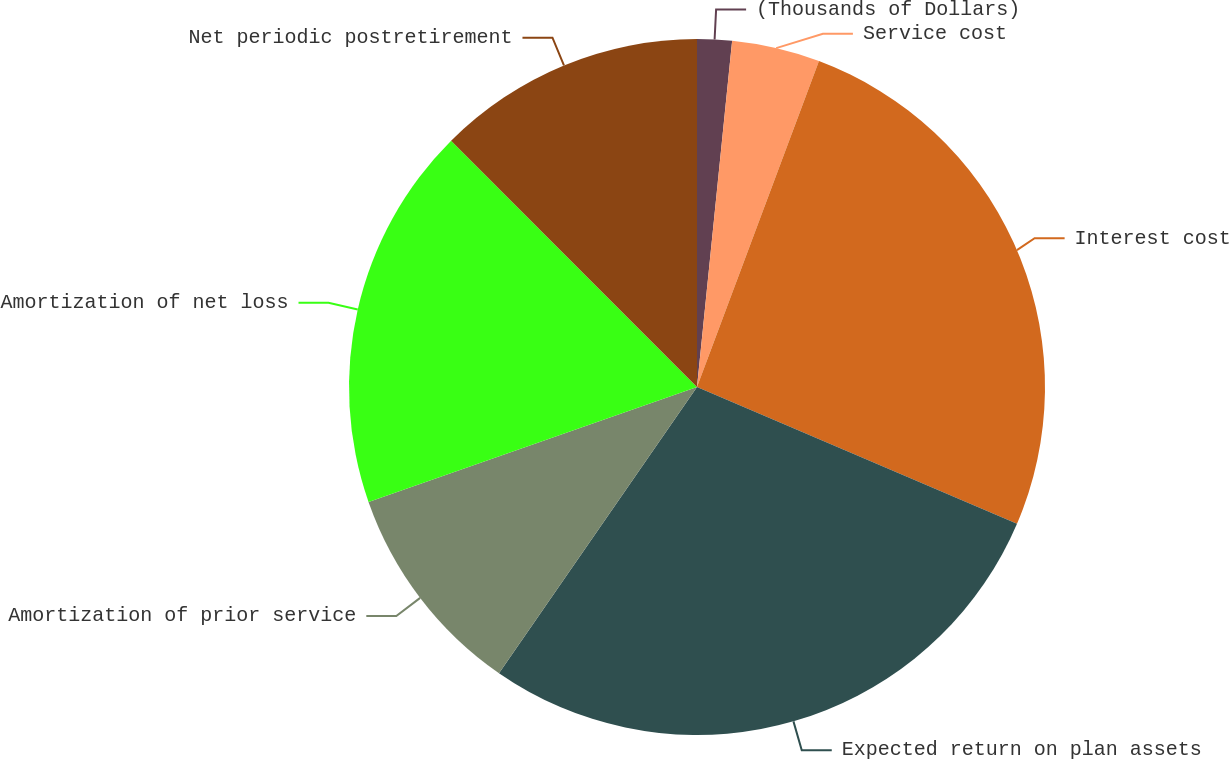<chart> <loc_0><loc_0><loc_500><loc_500><pie_chart><fcel>(Thousands of Dollars)<fcel>Service cost<fcel>Interest cost<fcel>Expected return on plan assets<fcel>Amortization of prior service<fcel>Amortization of net loss<fcel>Net periodic postretirement<nl><fcel>1.61%<fcel>4.09%<fcel>25.73%<fcel>28.21%<fcel>10.01%<fcel>17.87%<fcel>12.49%<nl></chart> 